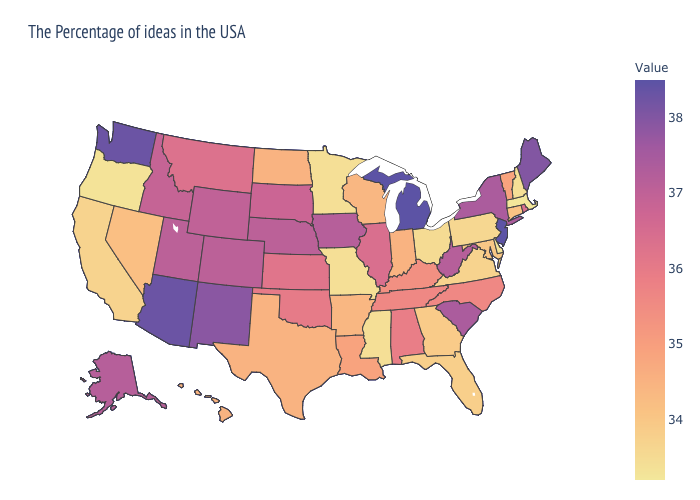Does Arizona have the highest value in the West?
Keep it brief. Yes. Among the states that border South Dakota , which have the highest value?
Answer briefly. Iowa. Does Delaware have the highest value in the USA?
Be succinct. No. Among the states that border Montana , which have the lowest value?
Keep it brief. North Dakota. Which states hav the highest value in the Northeast?
Short answer required. New Jersey. Does New York have the lowest value in the USA?
Concise answer only. No. Does New York have a lower value than New Jersey?
Give a very brief answer. Yes. Among the states that border North Dakota , does Montana have the highest value?
Be succinct. No. Among the states that border New Mexico , does Texas have the lowest value?
Short answer required. Yes. 